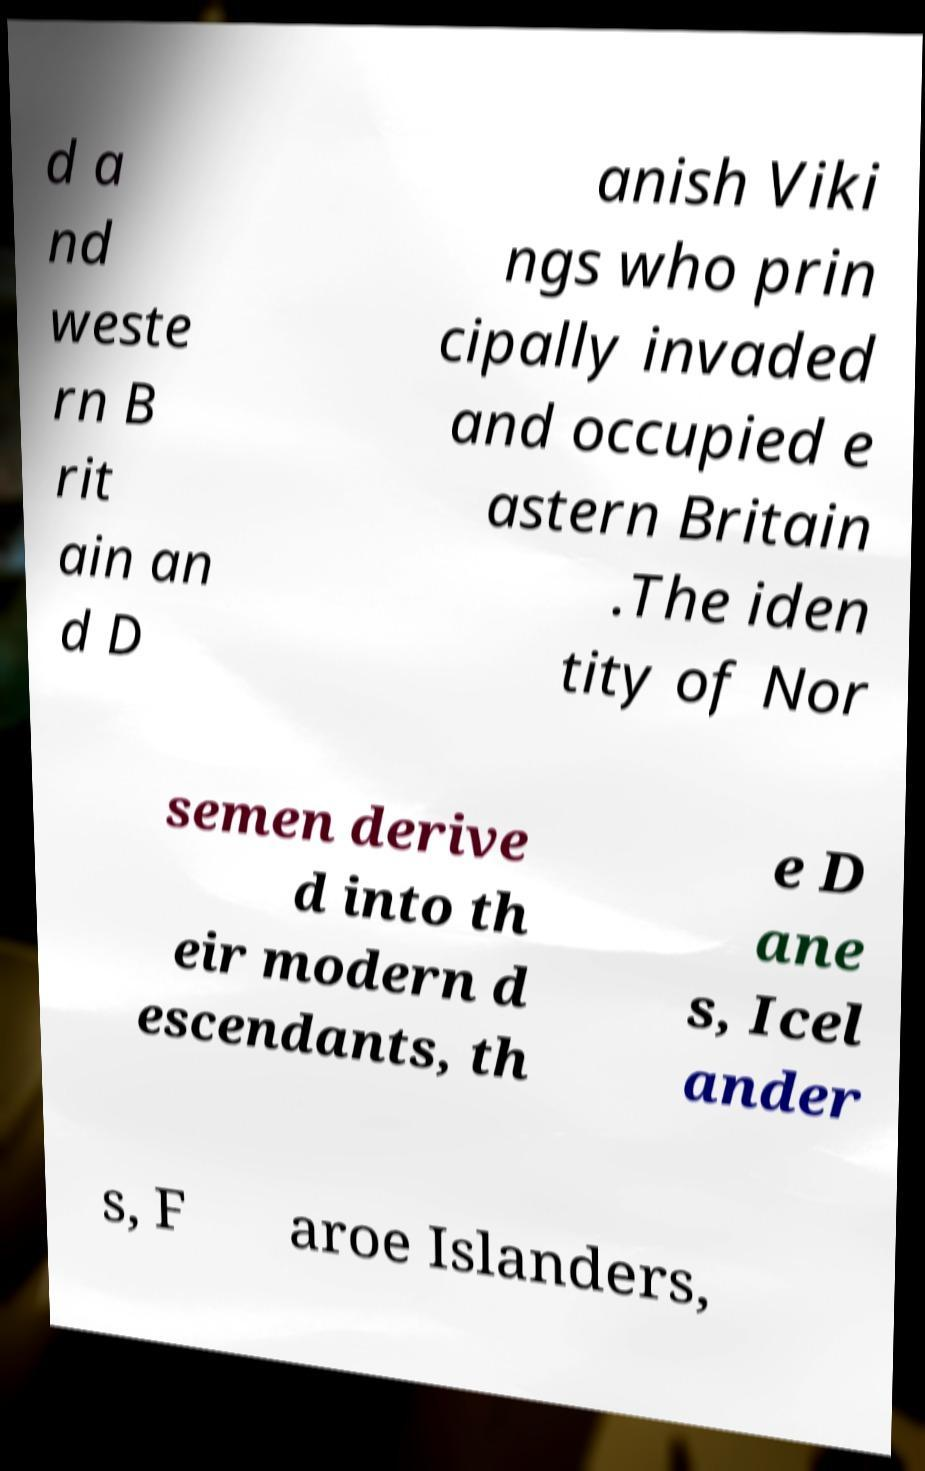Could you extract and type out the text from this image? d a nd weste rn B rit ain an d D anish Viki ngs who prin cipally invaded and occupied e astern Britain .The iden tity of Nor semen derive d into th eir modern d escendants, th e D ane s, Icel ander s, F aroe Islanders, 